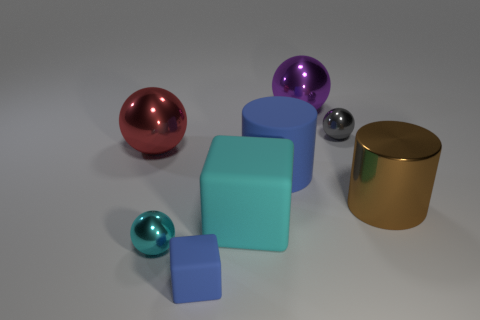How many blue rubber blocks are to the right of the big cyan matte thing?
Ensure brevity in your answer.  0. Is there a big gray ball that has the same material as the big purple ball?
Provide a short and direct response. No. There is a big object that is the same color as the tiny rubber object; what shape is it?
Offer a very short reply. Cylinder. There is a small metal object that is behind the large brown cylinder; what is its color?
Your response must be concise. Gray. Is the number of large cyan things behind the purple shiny thing the same as the number of big purple balls in front of the large brown thing?
Provide a succinct answer. Yes. The small ball that is behind the small sphere in front of the gray shiny ball is made of what material?
Offer a very short reply. Metal. What number of objects are red metal objects or large things to the left of the tiny gray shiny object?
Offer a terse response. 4. There is a cylinder that is made of the same material as the purple sphere; what size is it?
Your answer should be very brief. Large. Is the number of big red things on the left side of the big red shiny thing greater than the number of small purple metal cubes?
Keep it short and to the point. No. There is a metallic sphere that is both behind the cyan sphere and to the left of the big purple metallic object; what size is it?
Your response must be concise. Large. 